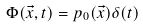<formula> <loc_0><loc_0><loc_500><loc_500>\Phi ( \vec { x } , t ) = p _ { 0 } ( \vec { x } ) \delta ( t )</formula> 